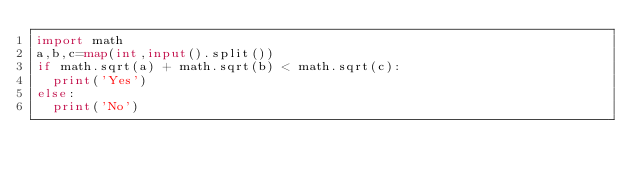Convert code to text. <code><loc_0><loc_0><loc_500><loc_500><_Python_>import math
a,b,c=map(int,input().split())
if math.sqrt(a) + math.sqrt(b) < math.sqrt(c):
  print('Yes')
else:
  print('No')</code> 